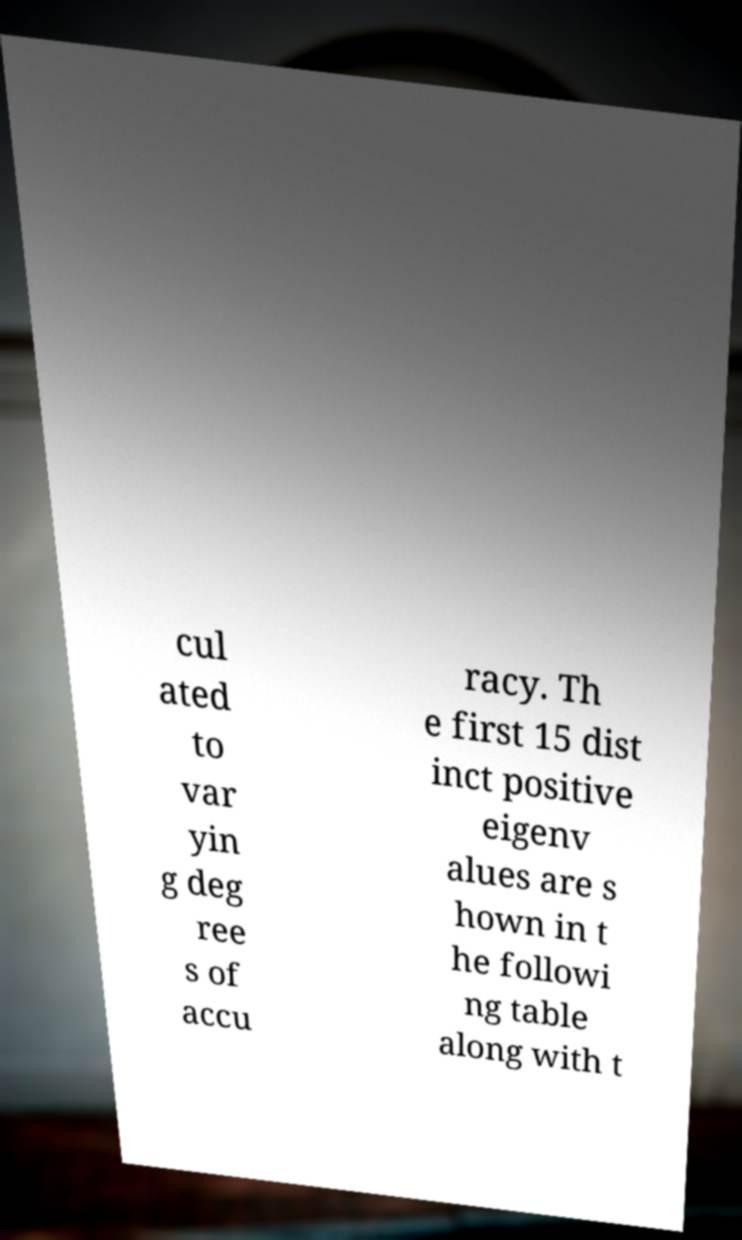Please identify and transcribe the text found in this image. cul ated to var yin g deg ree s of accu racy. Th e first 15 dist inct positive eigenv alues are s hown in t he followi ng table along with t 